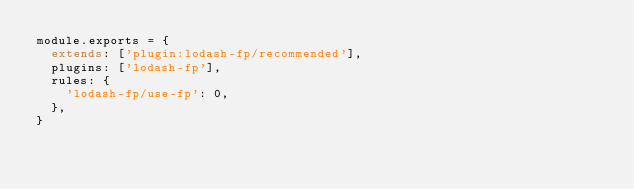Convert code to text. <code><loc_0><loc_0><loc_500><loc_500><_JavaScript_>module.exports = {
  extends: ['plugin:lodash-fp/recommended'],
  plugins: ['lodash-fp'],
  rules: {
    'lodash-fp/use-fp': 0,
  },
}
</code> 